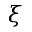Convert formula to latex. <formula><loc_0><loc_0><loc_500><loc_500>\xi</formula> 